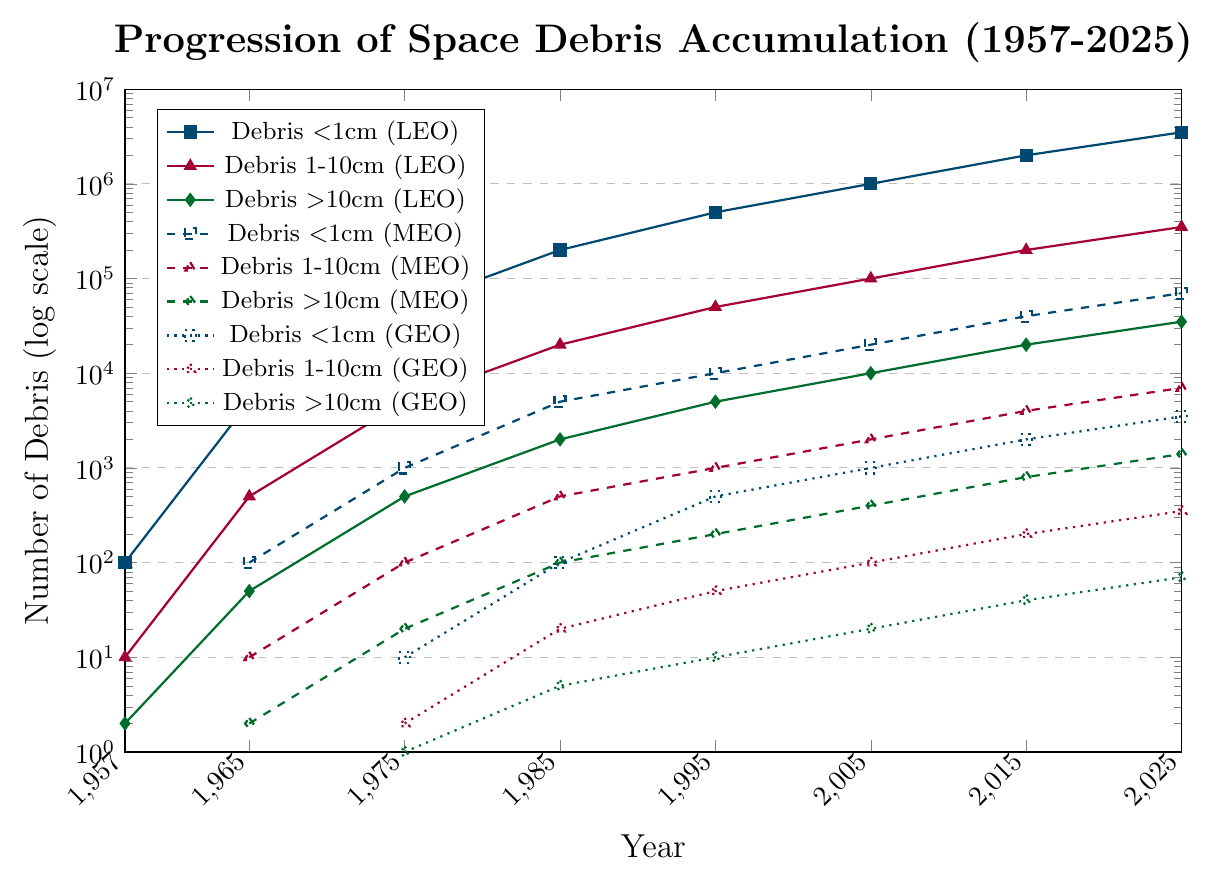How has the debris smaller than 1cm in LEO changed from 1957 to 2025? Observing the line for debris smaller than 1cm in LEO (depicted in blue with square markers), there is a clear exponential increase from 1957 (100 pieces) to 2025 (3,500,000 pieces). This demonstrates a substantial growth over time.
Answer: Increased significantly Which altitude and size category had the highest amount of debris in 2025? In 2025, the data point with the highest value belongs to debris smaller than 1cm in LEO, marked by the blue line with square markers, with a value of 3,500,000 pieces.
Answer: Debris smaller than 1cm in LEO How does the accumulation of debris 1-10cm in MEO compare to LEO in 2015? Referring to the red dashed line for MEO and the red solid line for LEO in 2015: LEO had 200,000 pieces, while MEO had 4,000 pieces. This indicates that LEO had significantly more debris in that size category than MEO.
Answer: LEO had significantly more What is the difference in the number of <1cm debris in GEO between 1985 and 2025? For <1cm debris in GEO (blue dotted line): In 1985, there were 100 pieces. In 2025, there were 3,500 pieces. The difference is 3,500 - 100 = 3,400 pieces.
Answer: 3,400 pieces Which category shows the most significant increase in debris between 1975 and 1985 in LEO? Comparing the values for LEO in 1975 and 1985: <1cm debris increased from 50,000 to 200,000 pieces; 1-10cm debris from 5,000 to 20,000 pieces; >10cm debris from 500 to 2,000 pieces. The <1cm category had the most significant increase, from 50,000 to 200,000 pieces (150,000 pieces).
Answer: <1cm debris in LEO What is the approximate ratio of debris >10cm in LEO to GEO in 1995? For 1995, >10cm debris in LEO (green line with diamonds) was 5,000 pieces and in GEO (green dotted line with diamonds) was 10 pieces. The ratio is approximately 5,000 / 10 = 500:1.
Answer: 500:1 Across all categories, which single category showed the lowest amount of debris in 2025? Reviewing all categories in 2025, the category with the lowest amount of debris is >10cm in GEO (green dotted line with diamonds), with 70 pieces.
Answer: >10cm debris in GEO What trend can be observed in the debris 1-10cm in MEO from 1957 to 2025? Focusing on the red dashed line for debris 1-10cm in MEO, the data starts at 0 in 1957 and steadily increases, reaching 7,000 in 2025. The trend shows a steady growth over time.
Answer: Steady increase How does the growth rate of <1cm debris in MEO from 2005 to 2025 compare to the growth rate from 1985 to 2005? For <1cm debris in MEO (blue dashed line): from 1985 (5,000 pieces) to 2005 (20,000 pieces), the increase was 15,000 pieces. From 2005 to 2025 (20,000 to 70,000 pieces), the increase was 50,000 pieces. The growth rate from 2005 to 2025 is higher.
Answer: Higher from 2005 to 2025 